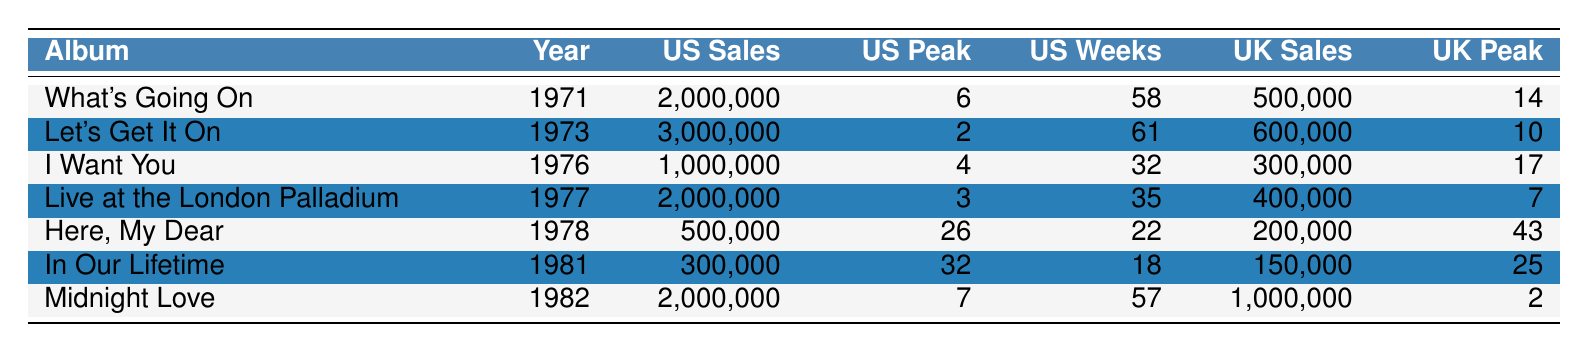What was the best-selling album in the US during the years 1971 to 1982? By looking at the sales figures in the US column, "Let's Get It On" has the highest sales at 3,000,000.
Answer: Let's Get It On Which album had the longest time on the US chart? "What's Going On" stayed on the US chart for 58 weeks, which is the longest compared to the others in the table.
Answer: What's Going On Did "Here, My Dear" peak at a higher position in the US or UK charts? "Here, My Dear" peaked at position 26 in the US and position 43 in the UK, so it peaked higher in the US.
Answer: Higher in the US What was the average sales in the US for Marvin Gaye's albums from 1971 to 1982? The US sales figures are 2,000,000 + 3,000,000 + 1,000,000 + 2,000,000 + 500,000 + 300,000 + 2,000,000 = 10,000,000. There are 7 albums, so the average is 10,000,000 / 7 ≈ 1,428,571.
Answer: 1,428,571 Which album had the lowest peak position in the US? The lowest peak position in the US is 32, which belongs to "In Our Lifetime."
Answer: In Our Lifetime What are the total sales of Marvin Gaye's albums in the UK? The UK sales are 500,000 + 600,000 + 300,000 + 400,000 + 200,000 + 150,000 + 1,000,000 = 3,150,000.
Answer: 3,150,000 Which album had both the highest US sales and the highest UK sales? "Let's Get It On" had the highest US sales at 3,000,000 and the highest UK sales at 600,000 among all the albums listed.
Answer: Let's Get It On Was the peak position of "Live at the London Palladium" higher in the US or UK? "Live at the London Palladium" peaked at position 3 in the US and position 7 in the UK, indicating it was higher in the US.
Answer: Higher in the US How much more did "Midnight Love" sell in the UK compared to "In Our Lifetime"? "Midnight Love" sold 1,000,000 in the UK, while "In Our Lifetime" sold 150,000. The difference is 1,000,000 - 150,000 = 850,000.
Answer: 850,000 What percentage of the total US sales does "Let's Get It On" represent? Total US sales are 10,000,000. "Let's Get It On" sold 3,000,000, so the percentage is (3,000,000 / 10,000,000) * 100 = 30%.
Answer: 30% 